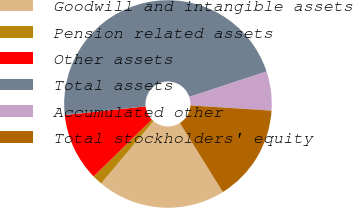Convert chart to OTSL. <chart><loc_0><loc_0><loc_500><loc_500><pie_chart><fcel>Goodwill and intangible assets<fcel>Pension related assets<fcel>Other assets<fcel>Total assets<fcel>Accumulated other<fcel>Total stockholders' equity<nl><fcel>20.0%<fcel>1.58%<fcel>10.59%<fcel>46.65%<fcel>6.08%<fcel>15.1%<nl></chart> 